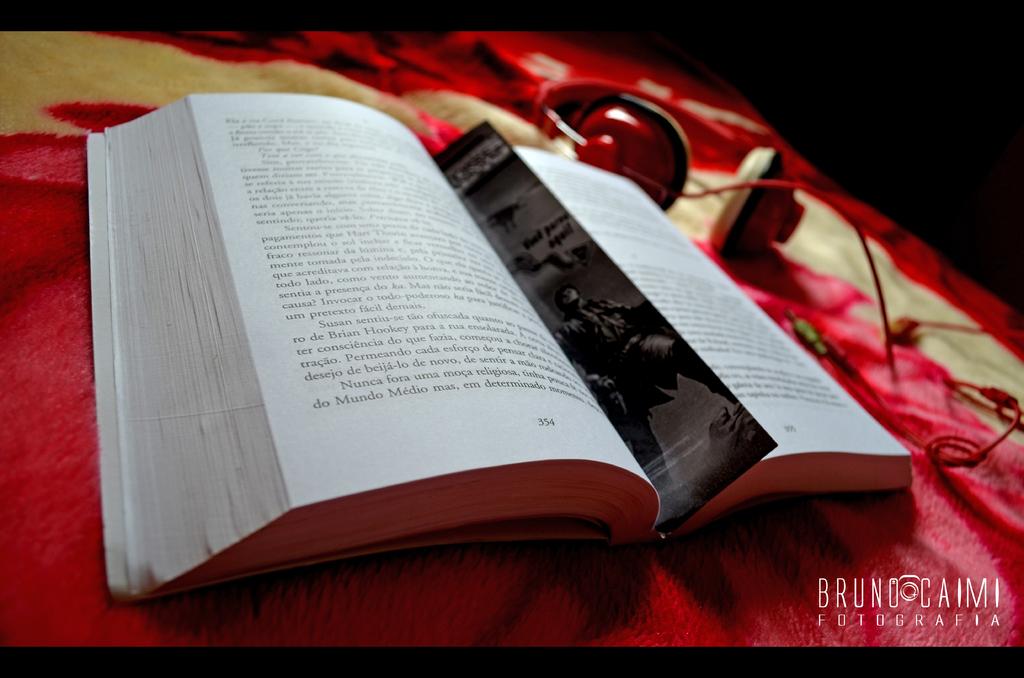Who is on the label of the photo?
Offer a terse response. Bruno caimi. What is the page number of the page on the left?
Your answer should be very brief. 354. 